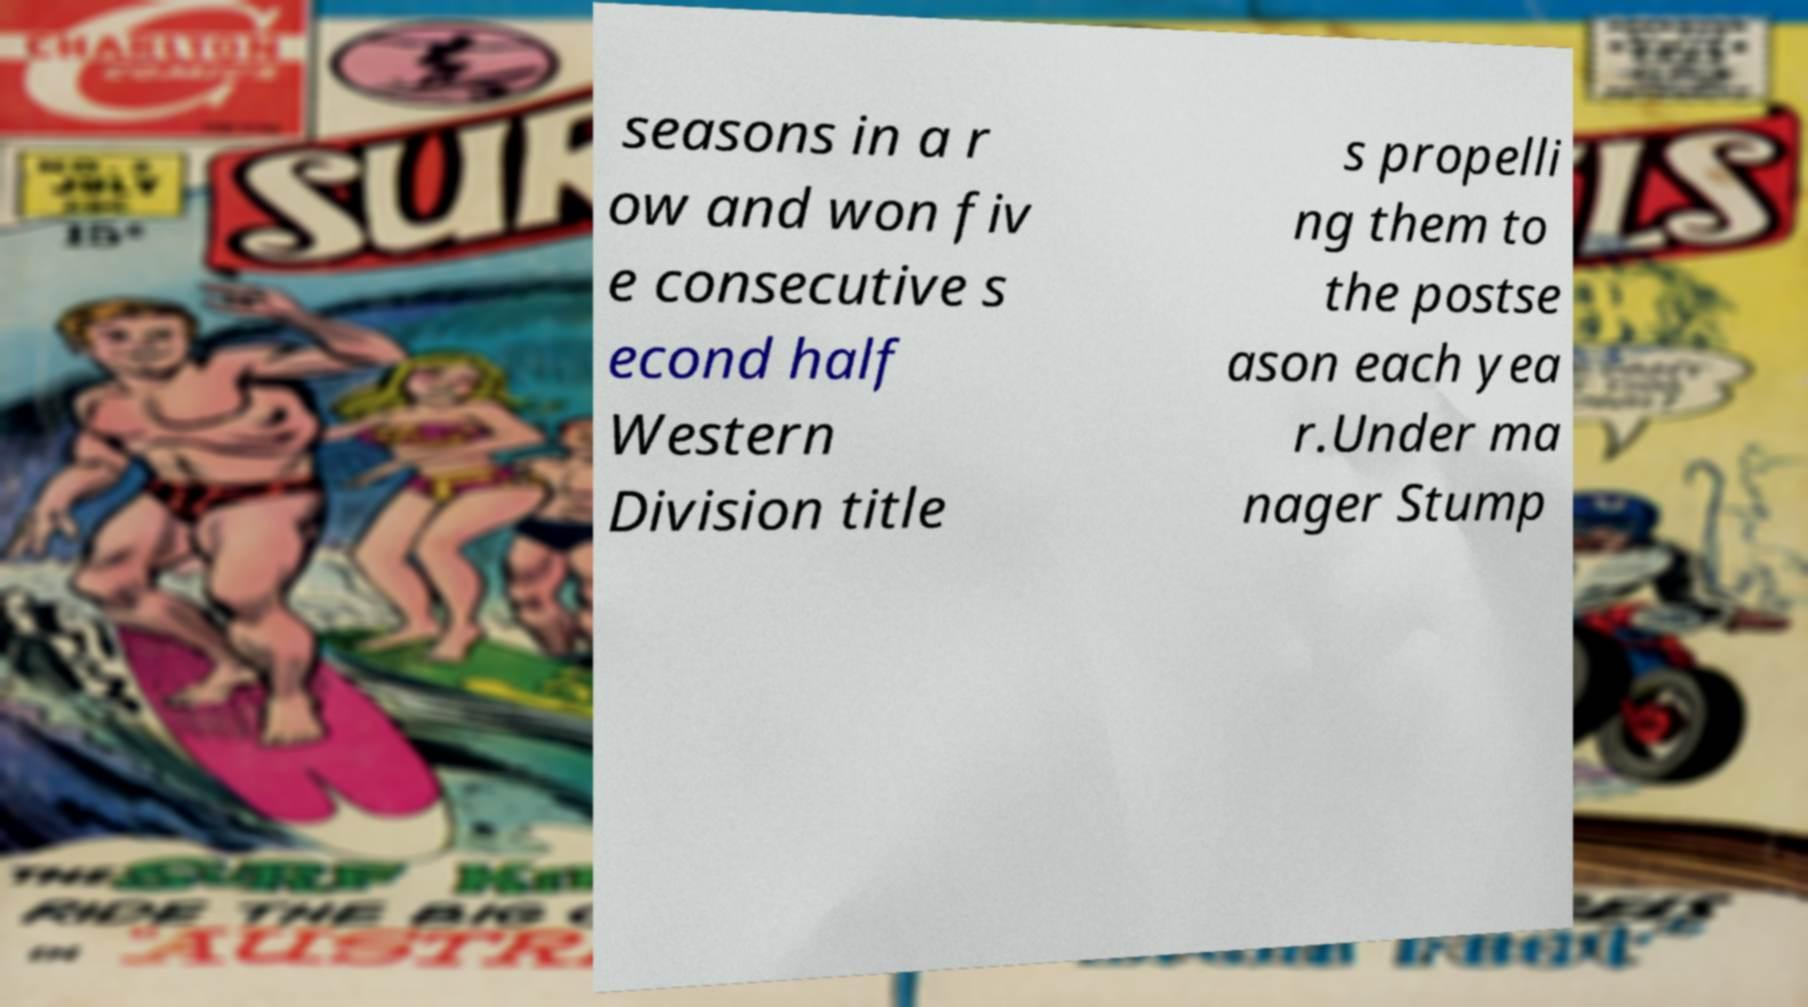I need the written content from this picture converted into text. Can you do that? seasons in a r ow and won fiv e consecutive s econd half Western Division title s propelli ng them to the postse ason each yea r.Under ma nager Stump 